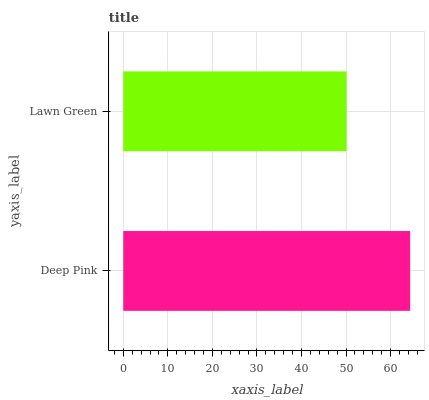Is Lawn Green the minimum?
Answer yes or no. Yes. Is Deep Pink the maximum?
Answer yes or no. Yes. Is Lawn Green the maximum?
Answer yes or no. No. Is Deep Pink greater than Lawn Green?
Answer yes or no. Yes. Is Lawn Green less than Deep Pink?
Answer yes or no. Yes. Is Lawn Green greater than Deep Pink?
Answer yes or no. No. Is Deep Pink less than Lawn Green?
Answer yes or no. No. Is Deep Pink the high median?
Answer yes or no. Yes. Is Lawn Green the low median?
Answer yes or no. Yes. Is Lawn Green the high median?
Answer yes or no. No. Is Deep Pink the low median?
Answer yes or no. No. 